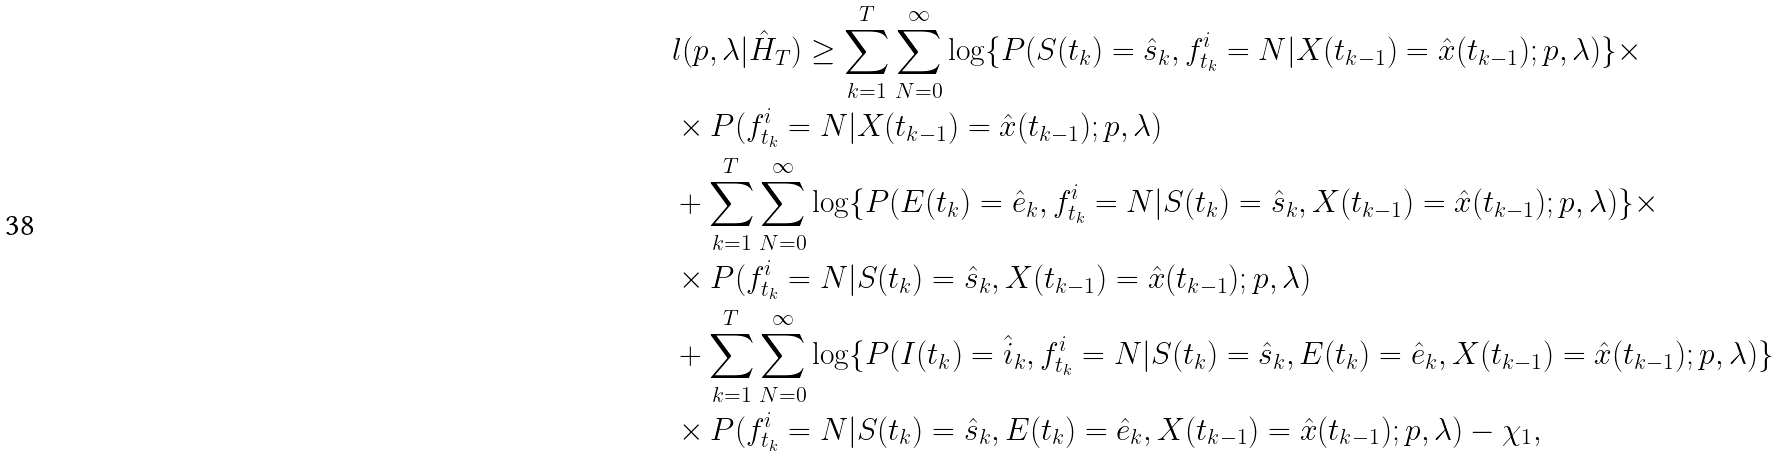Convert formula to latex. <formula><loc_0><loc_0><loc_500><loc_500>& l ( p , \lambda | \hat { H } _ { T } ) \geq \sum _ { k = 1 } ^ { T } \sum _ { N = 0 } ^ { \infty } \log \{ P ( S ( t _ { k } ) = \hat { s } _ { k } , f ^ { i } _ { t _ { k } } = N | X ( t _ { k - 1 } ) = \hat { x } ( t _ { k - 1 } ) ; p , \lambda ) \} \times \\ & \times P ( f ^ { i } _ { t _ { k } } = N | X ( t _ { k - 1 } ) = \hat { x } ( t _ { k - 1 } ) ; p , \lambda ) \\ & + \sum _ { k = 1 } ^ { T } \sum _ { N = 0 } ^ { \infty } \log \{ P ( E ( t _ { k } ) = \hat { e } _ { k } , f ^ { i } _ { t _ { k } } = N | S ( t _ { k } ) = \hat { s } _ { k } , X ( t _ { k - 1 } ) = \hat { x } ( t _ { k - 1 } ) ; p , \lambda ) \} \times \\ & \times P ( f ^ { i } _ { t _ { k } } = N | S ( t _ { k } ) = \hat { s } _ { k } , X ( t _ { k - 1 } ) = \hat { x } ( t _ { k - 1 } ) ; p , \lambda ) \\ & + \sum _ { k = 1 } ^ { T } \sum _ { N = 0 } ^ { \infty } \log \{ P ( I ( t _ { k } ) = \hat { i } _ { k } , f ^ { i } _ { t _ { k } } = N | S ( t _ { k } ) = \hat { s } _ { k } , E ( t _ { k } ) = \hat { e } _ { k } , X ( t _ { k - 1 } ) = \hat { x } ( t _ { k - 1 } ) ; p , \lambda ) \} \\ & \times P ( f ^ { i } _ { t _ { k } } = N | S ( t _ { k } ) = \hat { s } _ { k } , E ( t _ { k } ) = \hat { e } _ { k } , X ( t _ { k - 1 } ) = \hat { x } ( t _ { k - 1 } ) ; p , \lambda ) - \chi _ { 1 } ,</formula> 